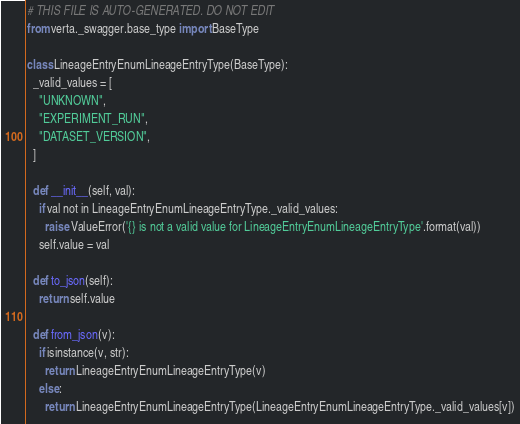<code> <loc_0><loc_0><loc_500><loc_500><_Python_># THIS FILE IS AUTO-GENERATED. DO NOT EDIT
from verta._swagger.base_type import BaseType

class LineageEntryEnumLineageEntryType(BaseType):
  _valid_values = [
    "UNKNOWN",
    "EXPERIMENT_RUN",
    "DATASET_VERSION",
  ]

  def __init__(self, val):
    if val not in LineageEntryEnumLineageEntryType._valid_values:
      raise ValueError('{} is not a valid value for LineageEntryEnumLineageEntryType'.format(val))
    self.value = val

  def to_json(self):
    return self.value

  def from_json(v):
    if isinstance(v, str):
      return LineageEntryEnumLineageEntryType(v)
    else:
      return LineageEntryEnumLineageEntryType(LineageEntryEnumLineageEntryType._valid_values[v])

</code> 